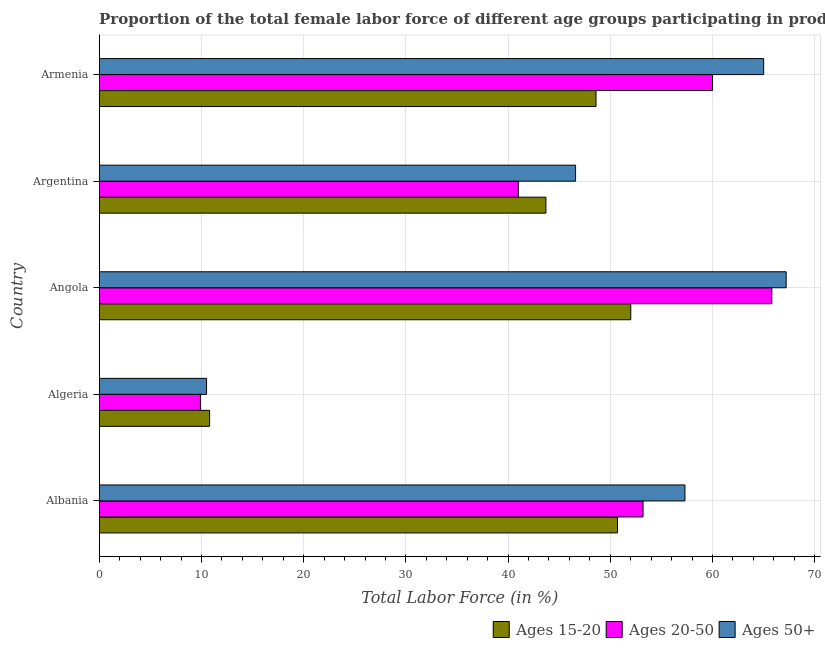How many different coloured bars are there?
Your answer should be compact. 3. How many groups of bars are there?
Your response must be concise. 5. Are the number of bars per tick equal to the number of legend labels?
Give a very brief answer. Yes. Are the number of bars on each tick of the Y-axis equal?
Offer a terse response. Yes. What is the label of the 4th group of bars from the top?
Your response must be concise. Algeria. What is the percentage of female labor force above age 50 in Argentina?
Provide a short and direct response. 46.6. Across all countries, what is the minimum percentage of female labor force within the age group 15-20?
Keep it short and to the point. 10.8. In which country was the percentage of female labor force above age 50 maximum?
Ensure brevity in your answer.  Angola. In which country was the percentage of female labor force within the age group 20-50 minimum?
Ensure brevity in your answer.  Algeria. What is the total percentage of female labor force above age 50 in the graph?
Your response must be concise. 246.6. What is the difference between the percentage of female labor force above age 50 in Armenia and the percentage of female labor force within the age group 15-20 in Algeria?
Your answer should be very brief. 54.2. What is the average percentage of female labor force within the age group 20-50 per country?
Give a very brief answer. 45.98. What is the ratio of the percentage of female labor force within the age group 15-20 in Algeria to that in Armenia?
Keep it short and to the point. 0.22. Is the difference between the percentage of female labor force within the age group 20-50 in Algeria and Angola greater than the difference between the percentage of female labor force within the age group 15-20 in Algeria and Angola?
Provide a short and direct response. No. What is the difference between the highest and the lowest percentage of female labor force within the age group 15-20?
Provide a succinct answer. 41.2. Is the sum of the percentage of female labor force within the age group 15-20 in Albania and Argentina greater than the maximum percentage of female labor force above age 50 across all countries?
Ensure brevity in your answer.  Yes. What does the 3rd bar from the top in Argentina represents?
Make the answer very short. Ages 15-20. What does the 2nd bar from the bottom in Angola represents?
Offer a very short reply. Ages 20-50. How many bars are there?
Offer a very short reply. 15. Are all the bars in the graph horizontal?
Your response must be concise. Yes. What is the difference between two consecutive major ticks on the X-axis?
Offer a very short reply. 10. Are the values on the major ticks of X-axis written in scientific E-notation?
Provide a short and direct response. No. Does the graph contain any zero values?
Your answer should be compact. No. How many legend labels are there?
Your response must be concise. 3. What is the title of the graph?
Offer a very short reply. Proportion of the total female labor force of different age groups participating in production in 1990. Does "Total employers" appear as one of the legend labels in the graph?
Your answer should be compact. No. What is the label or title of the Y-axis?
Offer a very short reply. Country. What is the Total Labor Force (in %) in Ages 15-20 in Albania?
Provide a succinct answer. 50.7. What is the Total Labor Force (in %) in Ages 20-50 in Albania?
Your answer should be very brief. 53.2. What is the Total Labor Force (in %) of Ages 50+ in Albania?
Your answer should be very brief. 57.3. What is the Total Labor Force (in %) in Ages 15-20 in Algeria?
Make the answer very short. 10.8. What is the Total Labor Force (in %) of Ages 20-50 in Algeria?
Your answer should be compact. 9.9. What is the Total Labor Force (in %) in Ages 50+ in Algeria?
Your answer should be compact. 10.5. What is the Total Labor Force (in %) of Ages 20-50 in Angola?
Provide a short and direct response. 65.8. What is the Total Labor Force (in %) of Ages 50+ in Angola?
Offer a very short reply. 67.2. What is the Total Labor Force (in %) in Ages 15-20 in Argentina?
Offer a terse response. 43.7. What is the Total Labor Force (in %) in Ages 20-50 in Argentina?
Provide a succinct answer. 41. What is the Total Labor Force (in %) of Ages 50+ in Argentina?
Offer a terse response. 46.6. What is the Total Labor Force (in %) in Ages 15-20 in Armenia?
Provide a succinct answer. 48.6. What is the Total Labor Force (in %) in Ages 20-50 in Armenia?
Your response must be concise. 60. What is the Total Labor Force (in %) in Ages 50+ in Armenia?
Ensure brevity in your answer.  65. Across all countries, what is the maximum Total Labor Force (in %) of Ages 15-20?
Provide a short and direct response. 52. Across all countries, what is the maximum Total Labor Force (in %) of Ages 20-50?
Your answer should be very brief. 65.8. Across all countries, what is the maximum Total Labor Force (in %) in Ages 50+?
Make the answer very short. 67.2. Across all countries, what is the minimum Total Labor Force (in %) in Ages 15-20?
Your answer should be compact. 10.8. Across all countries, what is the minimum Total Labor Force (in %) in Ages 20-50?
Keep it short and to the point. 9.9. What is the total Total Labor Force (in %) in Ages 15-20 in the graph?
Offer a terse response. 205.8. What is the total Total Labor Force (in %) of Ages 20-50 in the graph?
Provide a succinct answer. 229.9. What is the total Total Labor Force (in %) in Ages 50+ in the graph?
Offer a terse response. 246.6. What is the difference between the Total Labor Force (in %) in Ages 15-20 in Albania and that in Algeria?
Give a very brief answer. 39.9. What is the difference between the Total Labor Force (in %) in Ages 20-50 in Albania and that in Algeria?
Offer a very short reply. 43.3. What is the difference between the Total Labor Force (in %) of Ages 50+ in Albania and that in Algeria?
Your answer should be compact. 46.8. What is the difference between the Total Labor Force (in %) of Ages 15-20 in Albania and that in Angola?
Give a very brief answer. -1.3. What is the difference between the Total Labor Force (in %) of Ages 50+ in Albania and that in Angola?
Provide a succinct answer. -9.9. What is the difference between the Total Labor Force (in %) of Ages 50+ in Albania and that in Argentina?
Offer a terse response. 10.7. What is the difference between the Total Labor Force (in %) in Ages 15-20 in Algeria and that in Angola?
Offer a terse response. -41.2. What is the difference between the Total Labor Force (in %) in Ages 20-50 in Algeria and that in Angola?
Your answer should be very brief. -55.9. What is the difference between the Total Labor Force (in %) in Ages 50+ in Algeria and that in Angola?
Keep it short and to the point. -56.7. What is the difference between the Total Labor Force (in %) of Ages 15-20 in Algeria and that in Argentina?
Your answer should be compact. -32.9. What is the difference between the Total Labor Force (in %) of Ages 20-50 in Algeria and that in Argentina?
Provide a short and direct response. -31.1. What is the difference between the Total Labor Force (in %) of Ages 50+ in Algeria and that in Argentina?
Provide a short and direct response. -36.1. What is the difference between the Total Labor Force (in %) in Ages 15-20 in Algeria and that in Armenia?
Give a very brief answer. -37.8. What is the difference between the Total Labor Force (in %) in Ages 20-50 in Algeria and that in Armenia?
Your response must be concise. -50.1. What is the difference between the Total Labor Force (in %) of Ages 50+ in Algeria and that in Armenia?
Offer a terse response. -54.5. What is the difference between the Total Labor Force (in %) in Ages 20-50 in Angola and that in Argentina?
Keep it short and to the point. 24.8. What is the difference between the Total Labor Force (in %) of Ages 50+ in Angola and that in Argentina?
Offer a terse response. 20.6. What is the difference between the Total Labor Force (in %) of Ages 15-20 in Argentina and that in Armenia?
Give a very brief answer. -4.9. What is the difference between the Total Labor Force (in %) in Ages 20-50 in Argentina and that in Armenia?
Provide a short and direct response. -19. What is the difference between the Total Labor Force (in %) in Ages 50+ in Argentina and that in Armenia?
Offer a very short reply. -18.4. What is the difference between the Total Labor Force (in %) in Ages 15-20 in Albania and the Total Labor Force (in %) in Ages 20-50 in Algeria?
Offer a terse response. 40.8. What is the difference between the Total Labor Force (in %) in Ages 15-20 in Albania and the Total Labor Force (in %) in Ages 50+ in Algeria?
Ensure brevity in your answer.  40.2. What is the difference between the Total Labor Force (in %) of Ages 20-50 in Albania and the Total Labor Force (in %) of Ages 50+ in Algeria?
Offer a very short reply. 42.7. What is the difference between the Total Labor Force (in %) in Ages 15-20 in Albania and the Total Labor Force (in %) in Ages 20-50 in Angola?
Your answer should be very brief. -15.1. What is the difference between the Total Labor Force (in %) of Ages 15-20 in Albania and the Total Labor Force (in %) of Ages 50+ in Angola?
Make the answer very short. -16.5. What is the difference between the Total Labor Force (in %) in Ages 15-20 in Albania and the Total Labor Force (in %) in Ages 20-50 in Argentina?
Keep it short and to the point. 9.7. What is the difference between the Total Labor Force (in %) of Ages 20-50 in Albania and the Total Labor Force (in %) of Ages 50+ in Argentina?
Provide a succinct answer. 6.6. What is the difference between the Total Labor Force (in %) in Ages 15-20 in Albania and the Total Labor Force (in %) in Ages 50+ in Armenia?
Your answer should be compact. -14.3. What is the difference between the Total Labor Force (in %) of Ages 15-20 in Algeria and the Total Labor Force (in %) of Ages 20-50 in Angola?
Give a very brief answer. -55. What is the difference between the Total Labor Force (in %) in Ages 15-20 in Algeria and the Total Labor Force (in %) in Ages 50+ in Angola?
Your response must be concise. -56.4. What is the difference between the Total Labor Force (in %) in Ages 20-50 in Algeria and the Total Labor Force (in %) in Ages 50+ in Angola?
Your answer should be very brief. -57.3. What is the difference between the Total Labor Force (in %) of Ages 15-20 in Algeria and the Total Labor Force (in %) of Ages 20-50 in Argentina?
Provide a short and direct response. -30.2. What is the difference between the Total Labor Force (in %) in Ages 15-20 in Algeria and the Total Labor Force (in %) in Ages 50+ in Argentina?
Provide a short and direct response. -35.8. What is the difference between the Total Labor Force (in %) of Ages 20-50 in Algeria and the Total Labor Force (in %) of Ages 50+ in Argentina?
Provide a succinct answer. -36.7. What is the difference between the Total Labor Force (in %) in Ages 15-20 in Algeria and the Total Labor Force (in %) in Ages 20-50 in Armenia?
Ensure brevity in your answer.  -49.2. What is the difference between the Total Labor Force (in %) in Ages 15-20 in Algeria and the Total Labor Force (in %) in Ages 50+ in Armenia?
Make the answer very short. -54.2. What is the difference between the Total Labor Force (in %) in Ages 20-50 in Algeria and the Total Labor Force (in %) in Ages 50+ in Armenia?
Ensure brevity in your answer.  -55.1. What is the difference between the Total Labor Force (in %) of Ages 15-20 in Angola and the Total Labor Force (in %) of Ages 20-50 in Argentina?
Your answer should be very brief. 11. What is the difference between the Total Labor Force (in %) of Ages 15-20 in Angola and the Total Labor Force (in %) of Ages 50+ in Armenia?
Your answer should be compact. -13. What is the difference between the Total Labor Force (in %) in Ages 20-50 in Angola and the Total Labor Force (in %) in Ages 50+ in Armenia?
Make the answer very short. 0.8. What is the difference between the Total Labor Force (in %) in Ages 15-20 in Argentina and the Total Labor Force (in %) in Ages 20-50 in Armenia?
Offer a terse response. -16.3. What is the difference between the Total Labor Force (in %) of Ages 15-20 in Argentina and the Total Labor Force (in %) of Ages 50+ in Armenia?
Offer a very short reply. -21.3. What is the average Total Labor Force (in %) of Ages 15-20 per country?
Provide a succinct answer. 41.16. What is the average Total Labor Force (in %) in Ages 20-50 per country?
Your answer should be very brief. 45.98. What is the average Total Labor Force (in %) of Ages 50+ per country?
Your answer should be compact. 49.32. What is the difference between the Total Labor Force (in %) of Ages 15-20 and Total Labor Force (in %) of Ages 20-50 in Albania?
Your response must be concise. -2.5. What is the difference between the Total Labor Force (in %) of Ages 20-50 and Total Labor Force (in %) of Ages 50+ in Albania?
Keep it short and to the point. -4.1. What is the difference between the Total Labor Force (in %) in Ages 15-20 and Total Labor Force (in %) in Ages 20-50 in Algeria?
Your answer should be compact. 0.9. What is the difference between the Total Labor Force (in %) of Ages 15-20 and Total Labor Force (in %) of Ages 50+ in Algeria?
Your response must be concise. 0.3. What is the difference between the Total Labor Force (in %) of Ages 20-50 and Total Labor Force (in %) of Ages 50+ in Algeria?
Provide a succinct answer. -0.6. What is the difference between the Total Labor Force (in %) of Ages 15-20 and Total Labor Force (in %) of Ages 50+ in Angola?
Provide a short and direct response. -15.2. What is the difference between the Total Labor Force (in %) in Ages 20-50 and Total Labor Force (in %) in Ages 50+ in Angola?
Keep it short and to the point. -1.4. What is the difference between the Total Labor Force (in %) of Ages 15-20 and Total Labor Force (in %) of Ages 50+ in Argentina?
Make the answer very short. -2.9. What is the difference between the Total Labor Force (in %) in Ages 15-20 and Total Labor Force (in %) in Ages 50+ in Armenia?
Your answer should be compact. -16.4. What is the ratio of the Total Labor Force (in %) in Ages 15-20 in Albania to that in Algeria?
Make the answer very short. 4.69. What is the ratio of the Total Labor Force (in %) in Ages 20-50 in Albania to that in Algeria?
Offer a terse response. 5.37. What is the ratio of the Total Labor Force (in %) in Ages 50+ in Albania to that in Algeria?
Ensure brevity in your answer.  5.46. What is the ratio of the Total Labor Force (in %) in Ages 15-20 in Albania to that in Angola?
Make the answer very short. 0.97. What is the ratio of the Total Labor Force (in %) in Ages 20-50 in Albania to that in Angola?
Provide a short and direct response. 0.81. What is the ratio of the Total Labor Force (in %) in Ages 50+ in Albania to that in Angola?
Provide a succinct answer. 0.85. What is the ratio of the Total Labor Force (in %) in Ages 15-20 in Albania to that in Argentina?
Provide a short and direct response. 1.16. What is the ratio of the Total Labor Force (in %) in Ages 20-50 in Albania to that in Argentina?
Offer a very short reply. 1.3. What is the ratio of the Total Labor Force (in %) in Ages 50+ in Albania to that in Argentina?
Offer a terse response. 1.23. What is the ratio of the Total Labor Force (in %) of Ages 15-20 in Albania to that in Armenia?
Offer a very short reply. 1.04. What is the ratio of the Total Labor Force (in %) of Ages 20-50 in Albania to that in Armenia?
Provide a succinct answer. 0.89. What is the ratio of the Total Labor Force (in %) in Ages 50+ in Albania to that in Armenia?
Give a very brief answer. 0.88. What is the ratio of the Total Labor Force (in %) of Ages 15-20 in Algeria to that in Angola?
Provide a short and direct response. 0.21. What is the ratio of the Total Labor Force (in %) in Ages 20-50 in Algeria to that in Angola?
Give a very brief answer. 0.15. What is the ratio of the Total Labor Force (in %) in Ages 50+ in Algeria to that in Angola?
Keep it short and to the point. 0.16. What is the ratio of the Total Labor Force (in %) in Ages 15-20 in Algeria to that in Argentina?
Make the answer very short. 0.25. What is the ratio of the Total Labor Force (in %) in Ages 20-50 in Algeria to that in Argentina?
Keep it short and to the point. 0.24. What is the ratio of the Total Labor Force (in %) of Ages 50+ in Algeria to that in Argentina?
Your answer should be compact. 0.23. What is the ratio of the Total Labor Force (in %) in Ages 15-20 in Algeria to that in Armenia?
Provide a succinct answer. 0.22. What is the ratio of the Total Labor Force (in %) in Ages 20-50 in Algeria to that in Armenia?
Offer a very short reply. 0.17. What is the ratio of the Total Labor Force (in %) of Ages 50+ in Algeria to that in Armenia?
Give a very brief answer. 0.16. What is the ratio of the Total Labor Force (in %) in Ages 15-20 in Angola to that in Argentina?
Your response must be concise. 1.19. What is the ratio of the Total Labor Force (in %) of Ages 20-50 in Angola to that in Argentina?
Provide a succinct answer. 1.6. What is the ratio of the Total Labor Force (in %) of Ages 50+ in Angola to that in Argentina?
Your answer should be compact. 1.44. What is the ratio of the Total Labor Force (in %) of Ages 15-20 in Angola to that in Armenia?
Give a very brief answer. 1.07. What is the ratio of the Total Labor Force (in %) in Ages 20-50 in Angola to that in Armenia?
Your response must be concise. 1.1. What is the ratio of the Total Labor Force (in %) in Ages 50+ in Angola to that in Armenia?
Your response must be concise. 1.03. What is the ratio of the Total Labor Force (in %) of Ages 15-20 in Argentina to that in Armenia?
Your response must be concise. 0.9. What is the ratio of the Total Labor Force (in %) in Ages 20-50 in Argentina to that in Armenia?
Your response must be concise. 0.68. What is the ratio of the Total Labor Force (in %) of Ages 50+ in Argentina to that in Armenia?
Keep it short and to the point. 0.72. What is the difference between the highest and the second highest Total Labor Force (in %) of Ages 15-20?
Give a very brief answer. 1.3. What is the difference between the highest and the second highest Total Labor Force (in %) of Ages 20-50?
Keep it short and to the point. 5.8. What is the difference between the highest and the lowest Total Labor Force (in %) in Ages 15-20?
Provide a short and direct response. 41.2. What is the difference between the highest and the lowest Total Labor Force (in %) in Ages 20-50?
Give a very brief answer. 55.9. What is the difference between the highest and the lowest Total Labor Force (in %) of Ages 50+?
Your answer should be compact. 56.7. 